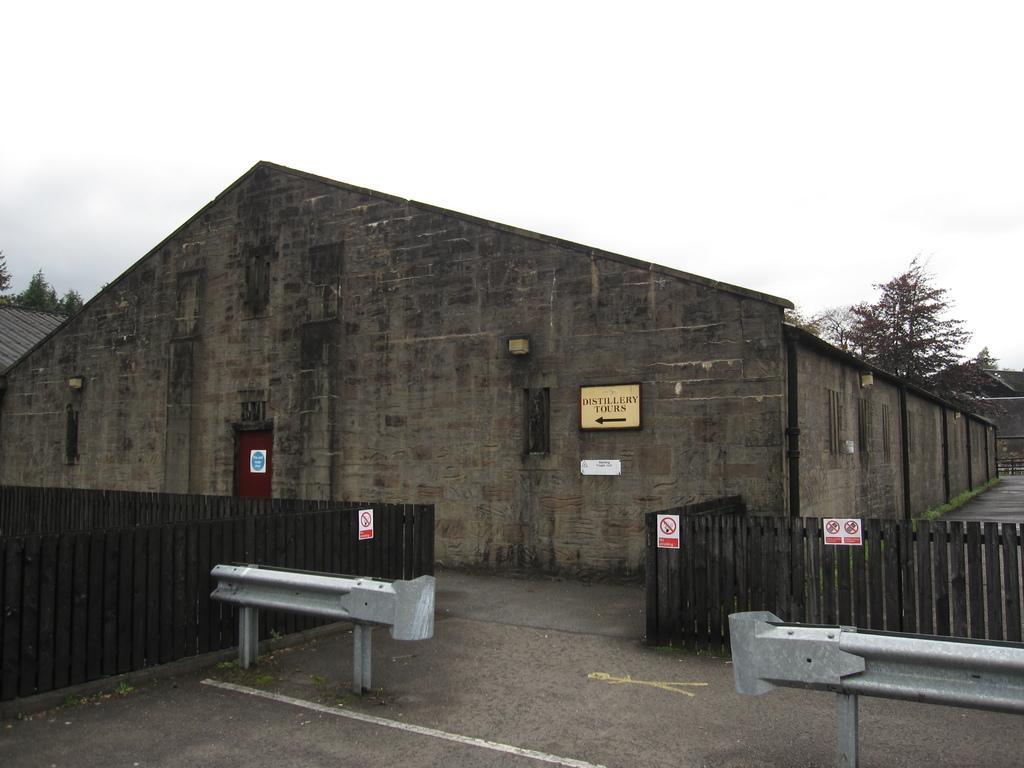Can you describe this image briefly? In this image there is a godown in the middle. There is wooden fence beside the godown. At the top there is the sky. In the background there are trees. At the bottom there are iron railings. 